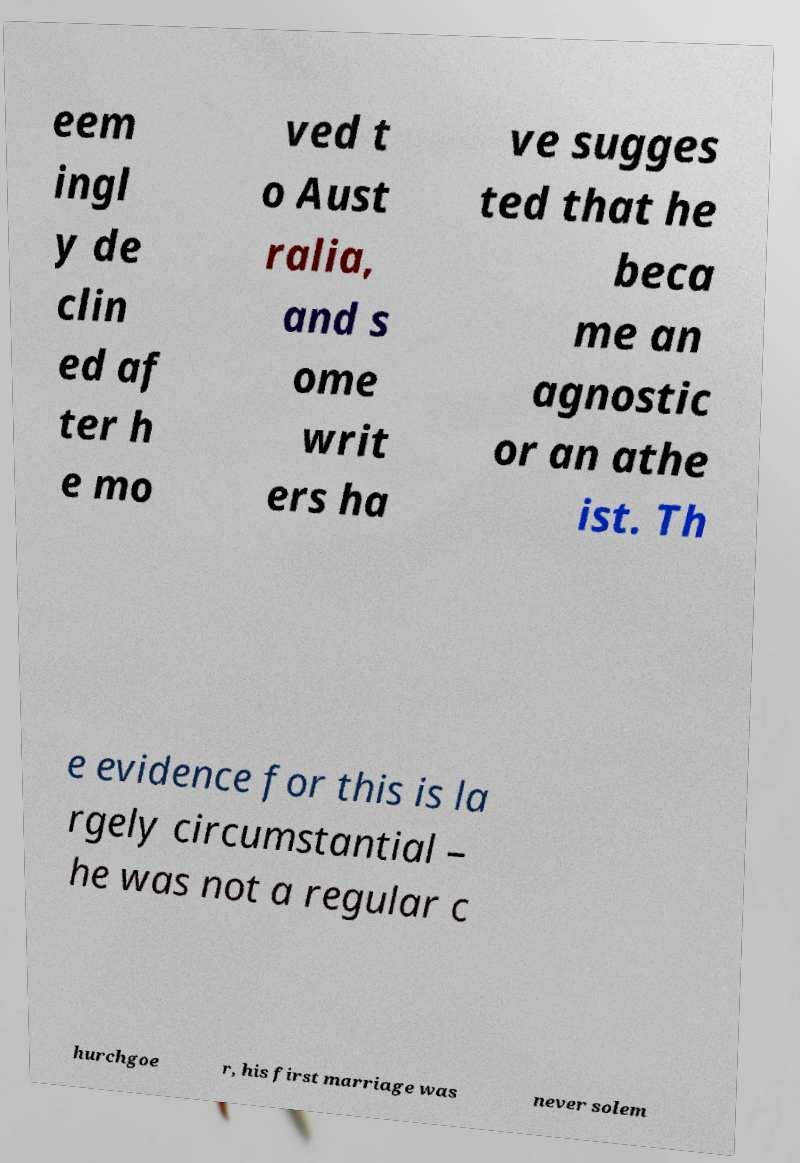Please identify and transcribe the text found in this image. eem ingl y de clin ed af ter h e mo ved t o Aust ralia, and s ome writ ers ha ve sugges ted that he beca me an agnostic or an athe ist. Th e evidence for this is la rgely circumstantial – he was not a regular c hurchgoe r, his first marriage was never solem 